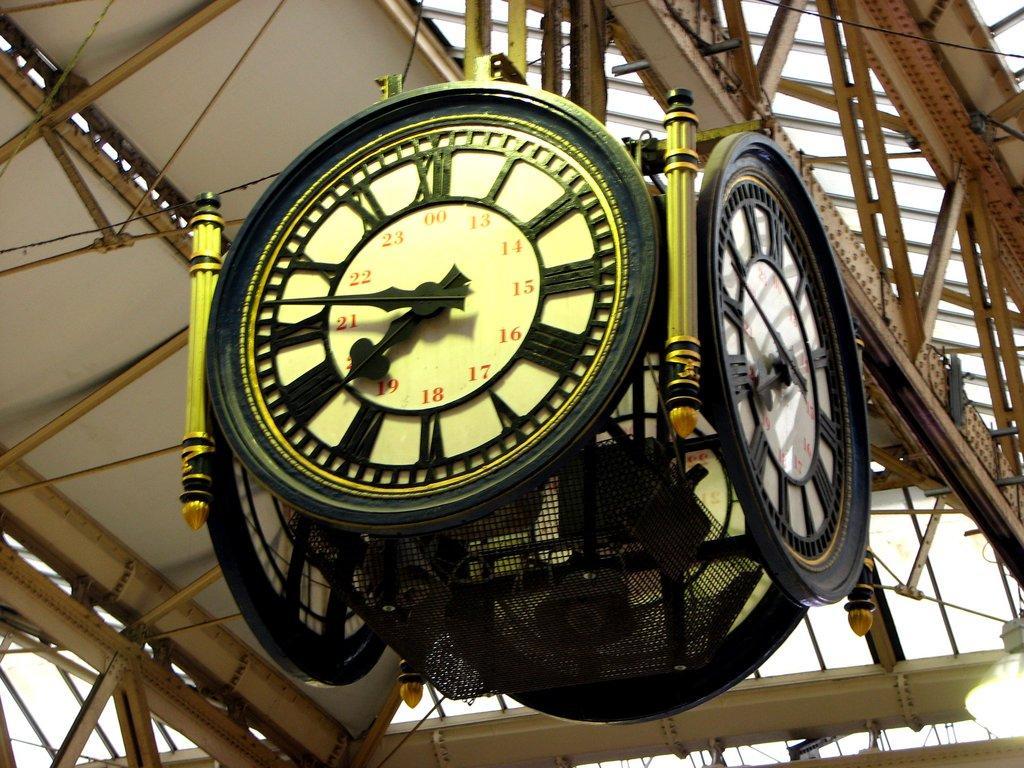How would you summarize this image in a sentence or two? In this image at the top there are clocks and there are stands and the sky is cloudy. 